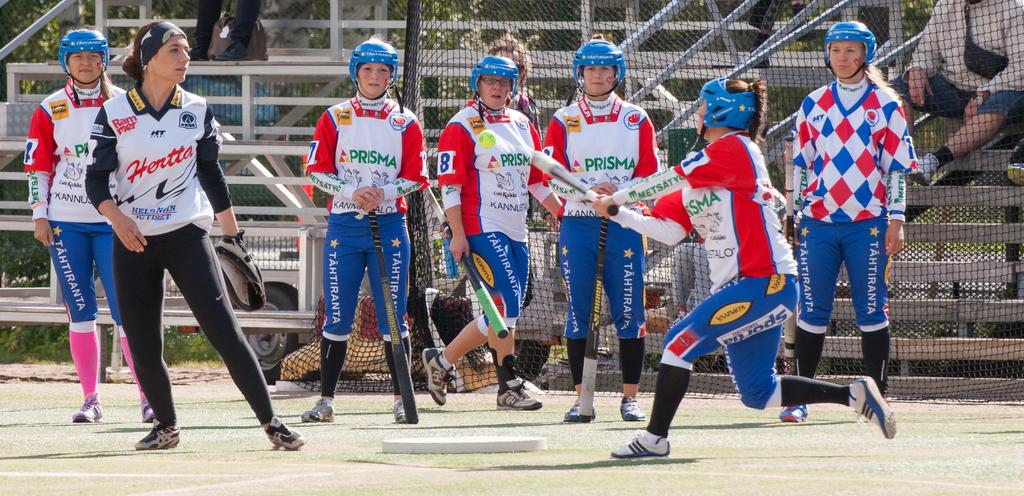Who sponsors that team?
Give a very brief answer. Prisma. 